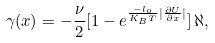Convert formula to latex. <formula><loc_0><loc_0><loc_500><loc_500>\gamma ( x ) = - \frac { \nu } { 2 } [ 1 - e ^ { \frac { - l _ { o } } { K _ { B } T } | \frac { \partial { U } } { \partial { x } } | } ] \, \aleph ,</formula> 